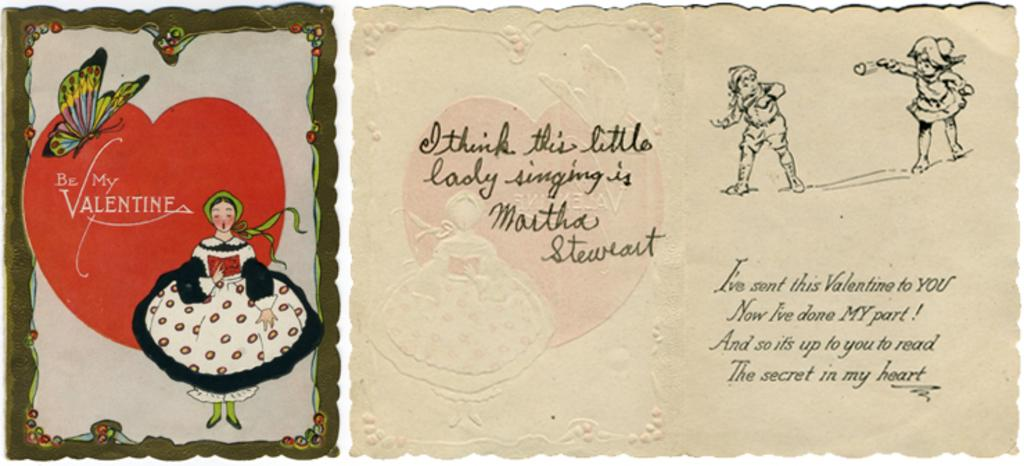What is the main subject of the image? There is a greeting card in the image. What is depicted on the greeting card? There is a butterfly, a lady singing, a girl throwing a heart, and a person receiving the heart on the greeting card. Can you describe the actions of the characters on the greeting card? The lady is singing, the girl is throwing a heart, and the person is receiving the heart. What type of sign can be seen in the image? There is no sign present in the image; it features a greeting card with various characters and actions. Is there a jail visible in the image? No, there is no jail present in the image. 